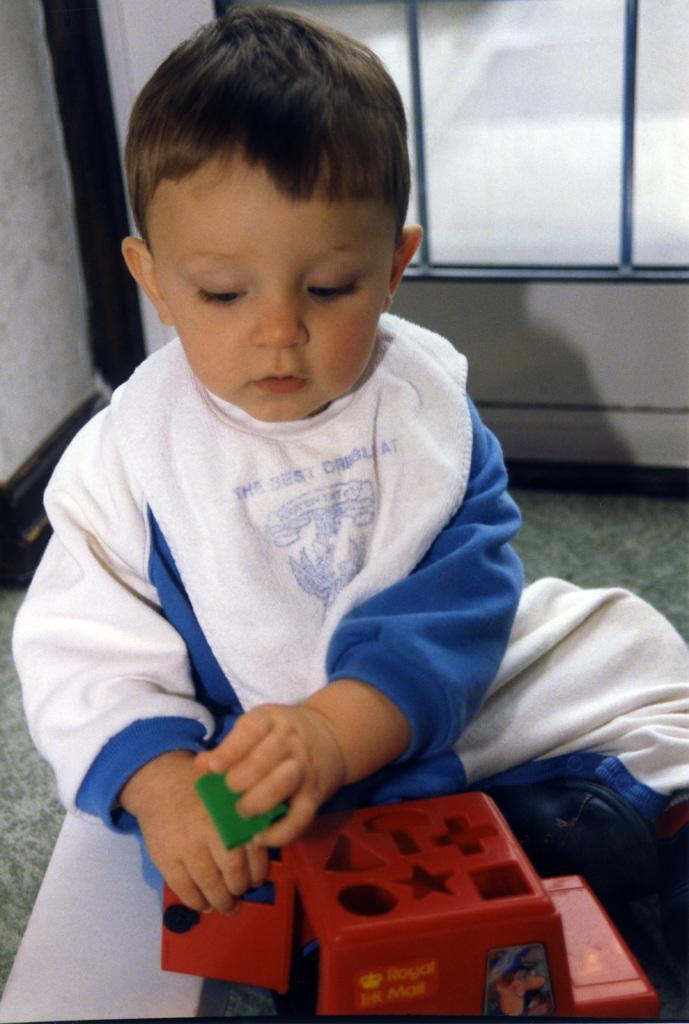Could you give a brief overview of what you see in this image? In this picture there is a boy sitting on the floor and holding a toy and an object. In the background of the image we can see wall and glass window. 